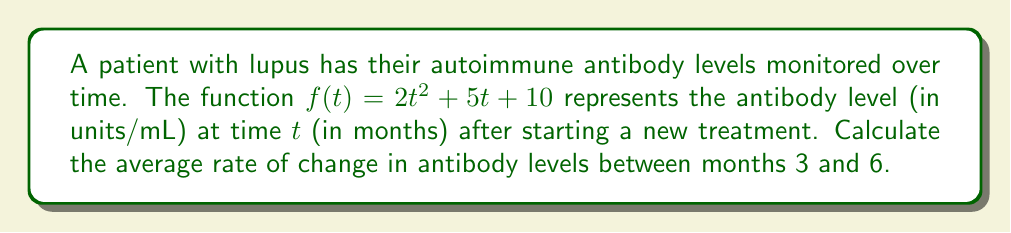What is the answer to this math problem? To find the average rate of change between two points, we use the formula:

$$\text{Average rate of change} = \frac{f(b) - f(a)}{b - a}$$

Where $a$ and $b$ are the start and end points of the time interval.

1) First, calculate $f(3)$:
   $f(3) = 2(3)^2 + 5(3) + 10 = 2(9) + 15 + 10 = 18 + 15 + 10 = 43$ units/mL

2) Next, calculate $f(6)$:
   $f(6) = 2(6)^2 + 5(6) + 10 = 2(36) + 30 + 10 = 72 + 30 + 10 = 112$ units/mL

3) Now, apply the average rate of change formula:
   $$\text{Average rate of change} = \frac{f(6) - f(3)}{6 - 3} = \frac{112 - 43}{3} = \frac{69}{3} = 23$$

Therefore, the average rate of change in antibody levels between months 3 and 6 is 23 units/mL per month.
Answer: 23 units/mL per month 